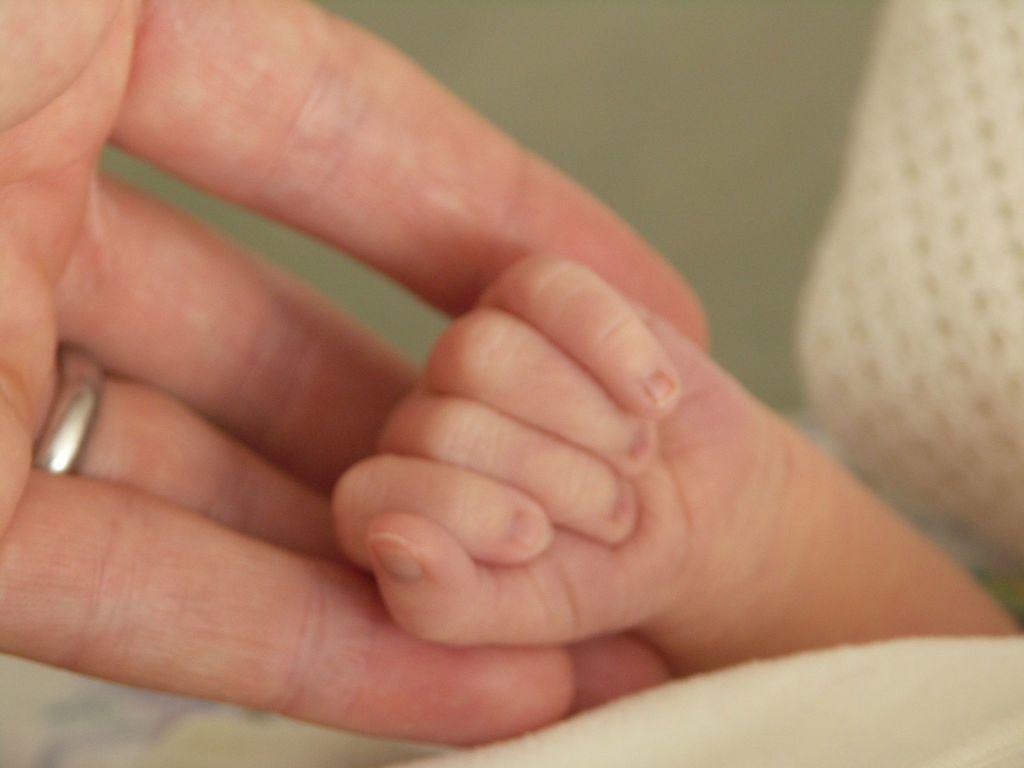How would you summarize this image in a sentence or two? In this picture we can see two hands and on right side we can see a hand of a baby and on left side we can see a hand of a person where trying to hold baby's hand and we can see a ring to the persons hand. 